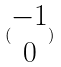<formula> <loc_0><loc_0><loc_500><loc_500>( \begin{matrix} - 1 \\ 0 \end{matrix} )</formula> 